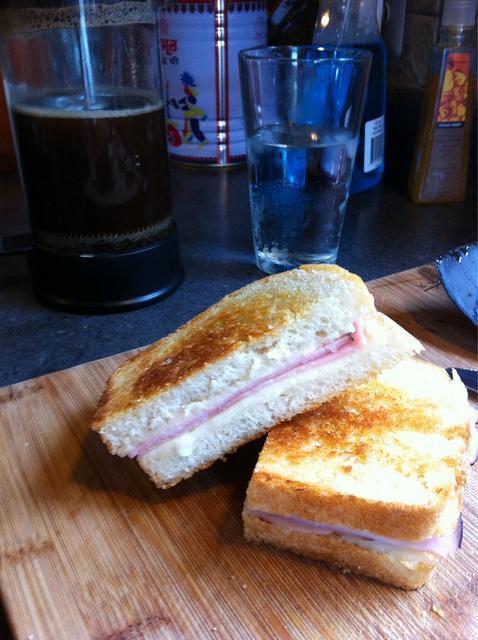What is the name of the container in the background holding coffee?
From the following four choices, select the correct answer to address the question.
Options: Aeropress coffee, french press, drip machine, coffee maker. French press. 